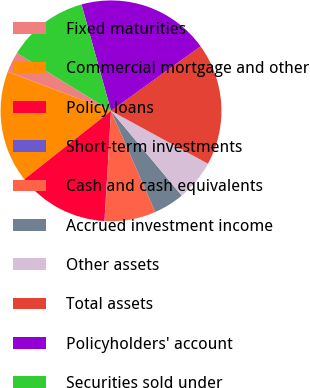Convert chart to OTSL. <chart><loc_0><loc_0><loc_500><loc_500><pie_chart><fcel>Fixed maturities<fcel>Commercial mortgage and other<fcel>Policy loans<fcel>Short-term investments<fcel>Cash and cash equivalents<fcel>Accrued investment income<fcel>Other assets<fcel>Total assets<fcel>Policyholders' account<fcel>Securities sold under<nl><fcel>3.01%<fcel>16.39%<fcel>13.42%<fcel>0.04%<fcel>7.47%<fcel>4.5%<fcel>5.99%<fcel>17.88%<fcel>19.37%<fcel>11.93%<nl></chart> 